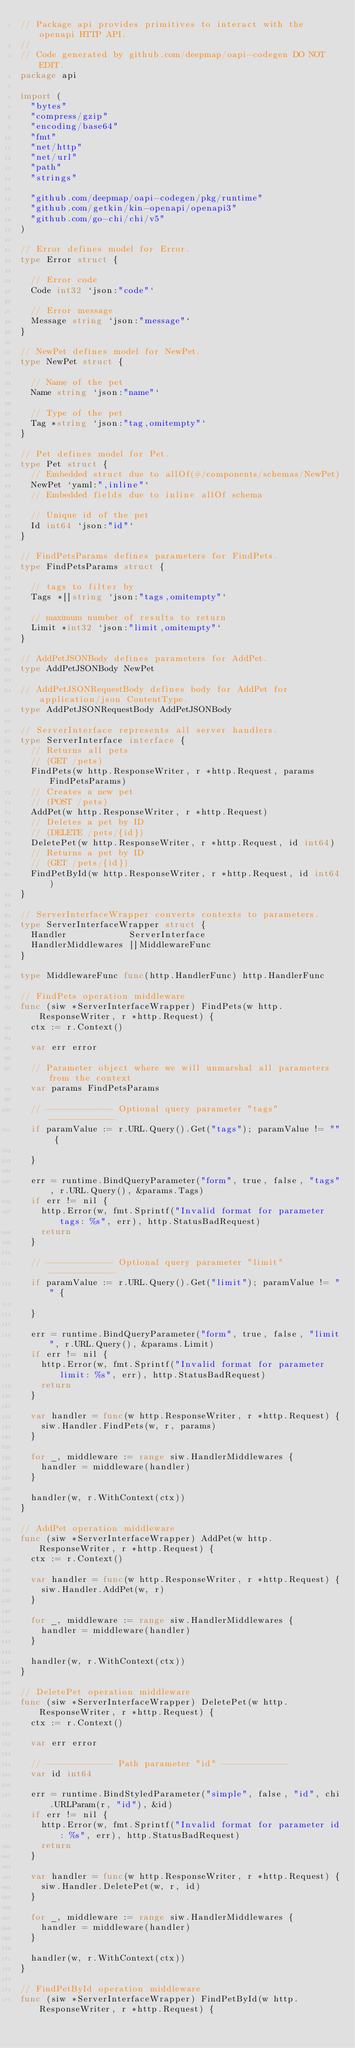Convert code to text. <code><loc_0><loc_0><loc_500><loc_500><_Go_>// Package api provides primitives to interact with the openapi HTTP API.
//
// Code generated by github.com/deepmap/oapi-codegen DO NOT EDIT.
package api

import (
	"bytes"
	"compress/gzip"
	"encoding/base64"
	"fmt"
	"net/http"
	"net/url"
	"path"
	"strings"

	"github.com/deepmap/oapi-codegen/pkg/runtime"
	"github.com/getkin/kin-openapi/openapi3"
	"github.com/go-chi/chi/v5"
)

// Error defines model for Error.
type Error struct {

	// Error code
	Code int32 `json:"code"`

	// Error message
	Message string `json:"message"`
}

// NewPet defines model for NewPet.
type NewPet struct {

	// Name of the pet
	Name string `json:"name"`

	// Type of the pet
	Tag *string `json:"tag,omitempty"`
}

// Pet defines model for Pet.
type Pet struct {
	// Embedded struct due to allOf(#/components/schemas/NewPet)
	NewPet `yaml:",inline"`
	// Embedded fields due to inline allOf schema

	// Unique id of the pet
	Id int64 `json:"id"`
}

// FindPetsParams defines parameters for FindPets.
type FindPetsParams struct {

	// tags to filter by
	Tags *[]string `json:"tags,omitempty"`

	// maximum number of results to return
	Limit *int32 `json:"limit,omitempty"`
}

// AddPetJSONBody defines parameters for AddPet.
type AddPetJSONBody NewPet

// AddPetJSONRequestBody defines body for AddPet for application/json ContentType.
type AddPetJSONRequestBody AddPetJSONBody

// ServerInterface represents all server handlers.
type ServerInterface interface {
	// Returns all pets
	// (GET /pets)
	FindPets(w http.ResponseWriter, r *http.Request, params FindPetsParams)
	// Creates a new pet
	// (POST /pets)
	AddPet(w http.ResponseWriter, r *http.Request)
	// Deletes a pet by ID
	// (DELETE /pets/{id})
	DeletePet(w http.ResponseWriter, r *http.Request, id int64)
	// Returns a pet by ID
	// (GET /pets/{id})
	FindPetById(w http.ResponseWriter, r *http.Request, id int64)
}

// ServerInterfaceWrapper converts contexts to parameters.
type ServerInterfaceWrapper struct {
	Handler            ServerInterface
	HandlerMiddlewares []MiddlewareFunc
}

type MiddlewareFunc func(http.HandlerFunc) http.HandlerFunc

// FindPets operation middleware
func (siw *ServerInterfaceWrapper) FindPets(w http.ResponseWriter, r *http.Request) {
	ctx := r.Context()

	var err error

	// Parameter object where we will unmarshal all parameters from the context
	var params FindPetsParams

	// ------------- Optional query parameter "tags" -------------
	if paramValue := r.URL.Query().Get("tags"); paramValue != "" {

	}

	err = runtime.BindQueryParameter("form", true, false, "tags", r.URL.Query(), &params.Tags)
	if err != nil {
		http.Error(w, fmt.Sprintf("Invalid format for parameter tags: %s", err), http.StatusBadRequest)
		return
	}

	// ------------- Optional query parameter "limit" -------------
	if paramValue := r.URL.Query().Get("limit"); paramValue != "" {

	}

	err = runtime.BindQueryParameter("form", true, false, "limit", r.URL.Query(), &params.Limit)
	if err != nil {
		http.Error(w, fmt.Sprintf("Invalid format for parameter limit: %s", err), http.StatusBadRequest)
		return
	}

	var handler = func(w http.ResponseWriter, r *http.Request) {
		siw.Handler.FindPets(w, r, params)
	}

	for _, middleware := range siw.HandlerMiddlewares {
		handler = middleware(handler)
	}

	handler(w, r.WithContext(ctx))
}

// AddPet operation middleware
func (siw *ServerInterfaceWrapper) AddPet(w http.ResponseWriter, r *http.Request) {
	ctx := r.Context()

	var handler = func(w http.ResponseWriter, r *http.Request) {
		siw.Handler.AddPet(w, r)
	}

	for _, middleware := range siw.HandlerMiddlewares {
		handler = middleware(handler)
	}

	handler(w, r.WithContext(ctx))
}

// DeletePet operation middleware
func (siw *ServerInterfaceWrapper) DeletePet(w http.ResponseWriter, r *http.Request) {
	ctx := r.Context()

	var err error

	// ------------- Path parameter "id" -------------
	var id int64

	err = runtime.BindStyledParameter("simple", false, "id", chi.URLParam(r, "id"), &id)
	if err != nil {
		http.Error(w, fmt.Sprintf("Invalid format for parameter id: %s", err), http.StatusBadRequest)
		return
	}

	var handler = func(w http.ResponseWriter, r *http.Request) {
		siw.Handler.DeletePet(w, r, id)
	}

	for _, middleware := range siw.HandlerMiddlewares {
		handler = middleware(handler)
	}

	handler(w, r.WithContext(ctx))
}

// FindPetById operation middleware
func (siw *ServerInterfaceWrapper) FindPetById(w http.ResponseWriter, r *http.Request) {</code> 